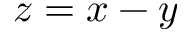Convert formula to latex. <formula><loc_0><loc_0><loc_500><loc_500>z = x - y</formula> 